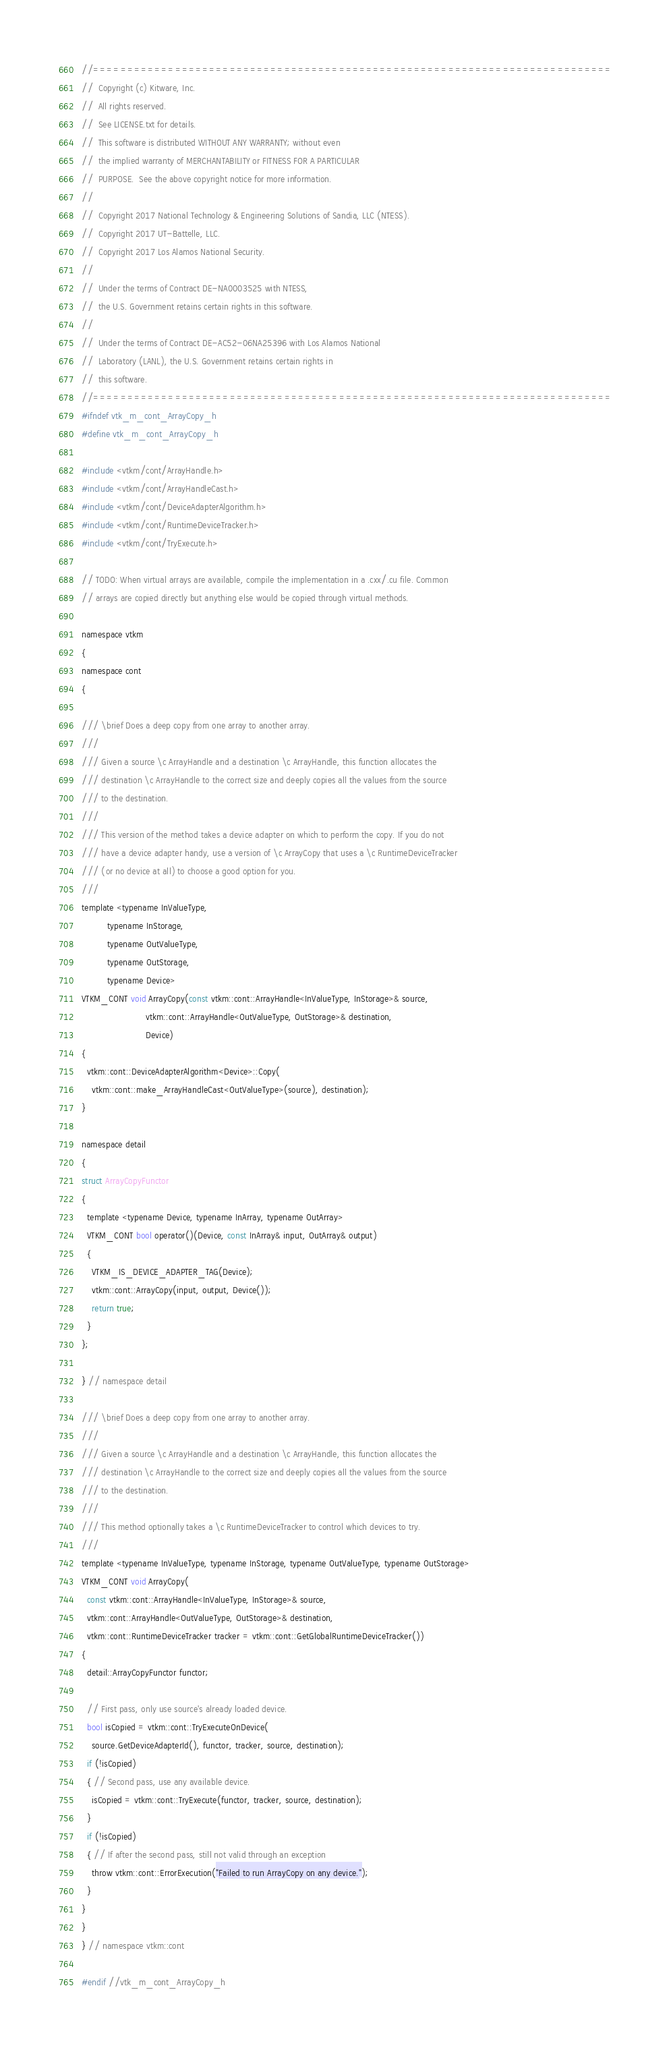<code> <loc_0><loc_0><loc_500><loc_500><_C_>//============================================================================
//  Copyright (c) Kitware, Inc.
//  All rights reserved.
//  See LICENSE.txt for details.
//  This software is distributed WITHOUT ANY WARRANTY; without even
//  the implied warranty of MERCHANTABILITY or FITNESS FOR A PARTICULAR
//  PURPOSE.  See the above copyright notice for more information.
//
//  Copyright 2017 National Technology & Engineering Solutions of Sandia, LLC (NTESS).
//  Copyright 2017 UT-Battelle, LLC.
//  Copyright 2017 Los Alamos National Security.
//
//  Under the terms of Contract DE-NA0003525 with NTESS,
//  the U.S. Government retains certain rights in this software.
//
//  Under the terms of Contract DE-AC52-06NA25396 with Los Alamos National
//  Laboratory (LANL), the U.S. Government retains certain rights in
//  this software.
//============================================================================
#ifndef vtk_m_cont_ArrayCopy_h
#define vtk_m_cont_ArrayCopy_h

#include <vtkm/cont/ArrayHandle.h>
#include <vtkm/cont/ArrayHandleCast.h>
#include <vtkm/cont/DeviceAdapterAlgorithm.h>
#include <vtkm/cont/RuntimeDeviceTracker.h>
#include <vtkm/cont/TryExecute.h>

// TODO: When virtual arrays are available, compile the implementation in a .cxx/.cu file. Common
// arrays are copied directly but anything else would be copied through virtual methods.

namespace vtkm
{
namespace cont
{

/// \brief Does a deep copy from one array to another array.
///
/// Given a source \c ArrayHandle and a destination \c ArrayHandle, this function allocates the
/// destination \c ArrayHandle to the correct size and deeply copies all the values from the source
/// to the destination.
///
/// This version of the method takes a device adapter on which to perform the copy. If you do not
/// have a device adapter handy, use a version of \c ArrayCopy that uses a \c RuntimeDeviceTracker
/// (or no device at all) to choose a good option for you.
///
template <typename InValueType,
          typename InStorage,
          typename OutValueType,
          typename OutStorage,
          typename Device>
VTKM_CONT void ArrayCopy(const vtkm::cont::ArrayHandle<InValueType, InStorage>& source,
                         vtkm::cont::ArrayHandle<OutValueType, OutStorage>& destination,
                         Device)
{
  vtkm::cont::DeviceAdapterAlgorithm<Device>::Copy(
    vtkm::cont::make_ArrayHandleCast<OutValueType>(source), destination);
}

namespace detail
{
struct ArrayCopyFunctor
{
  template <typename Device, typename InArray, typename OutArray>
  VTKM_CONT bool operator()(Device, const InArray& input, OutArray& output)
  {
    VTKM_IS_DEVICE_ADAPTER_TAG(Device);
    vtkm::cont::ArrayCopy(input, output, Device());
    return true;
  }
};

} // namespace detail

/// \brief Does a deep copy from one array to another array.
///
/// Given a source \c ArrayHandle and a destination \c ArrayHandle, this function allocates the
/// destination \c ArrayHandle to the correct size and deeply copies all the values from the source
/// to the destination.
///
/// This method optionally takes a \c RuntimeDeviceTracker to control which devices to try.
///
template <typename InValueType, typename InStorage, typename OutValueType, typename OutStorage>
VTKM_CONT void ArrayCopy(
  const vtkm::cont::ArrayHandle<InValueType, InStorage>& source,
  vtkm::cont::ArrayHandle<OutValueType, OutStorage>& destination,
  vtkm::cont::RuntimeDeviceTracker tracker = vtkm::cont::GetGlobalRuntimeDeviceTracker())
{
  detail::ArrayCopyFunctor functor;

  // First pass, only use source's already loaded device.
  bool isCopied = vtkm::cont::TryExecuteOnDevice(
    source.GetDeviceAdapterId(), functor, tracker, source, destination);
  if (!isCopied)
  { // Second pass, use any available device.
    isCopied = vtkm::cont::TryExecute(functor, tracker, source, destination);
  }
  if (!isCopied)
  { // If after the second pass, still not valid through an exception
    throw vtkm::cont::ErrorExecution("Failed to run ArrayCopy on any device.");
  }
}
}
} // namespace vtkm::cont

#endif //vtk_m_cont_ArrayCopy_h
</code> 